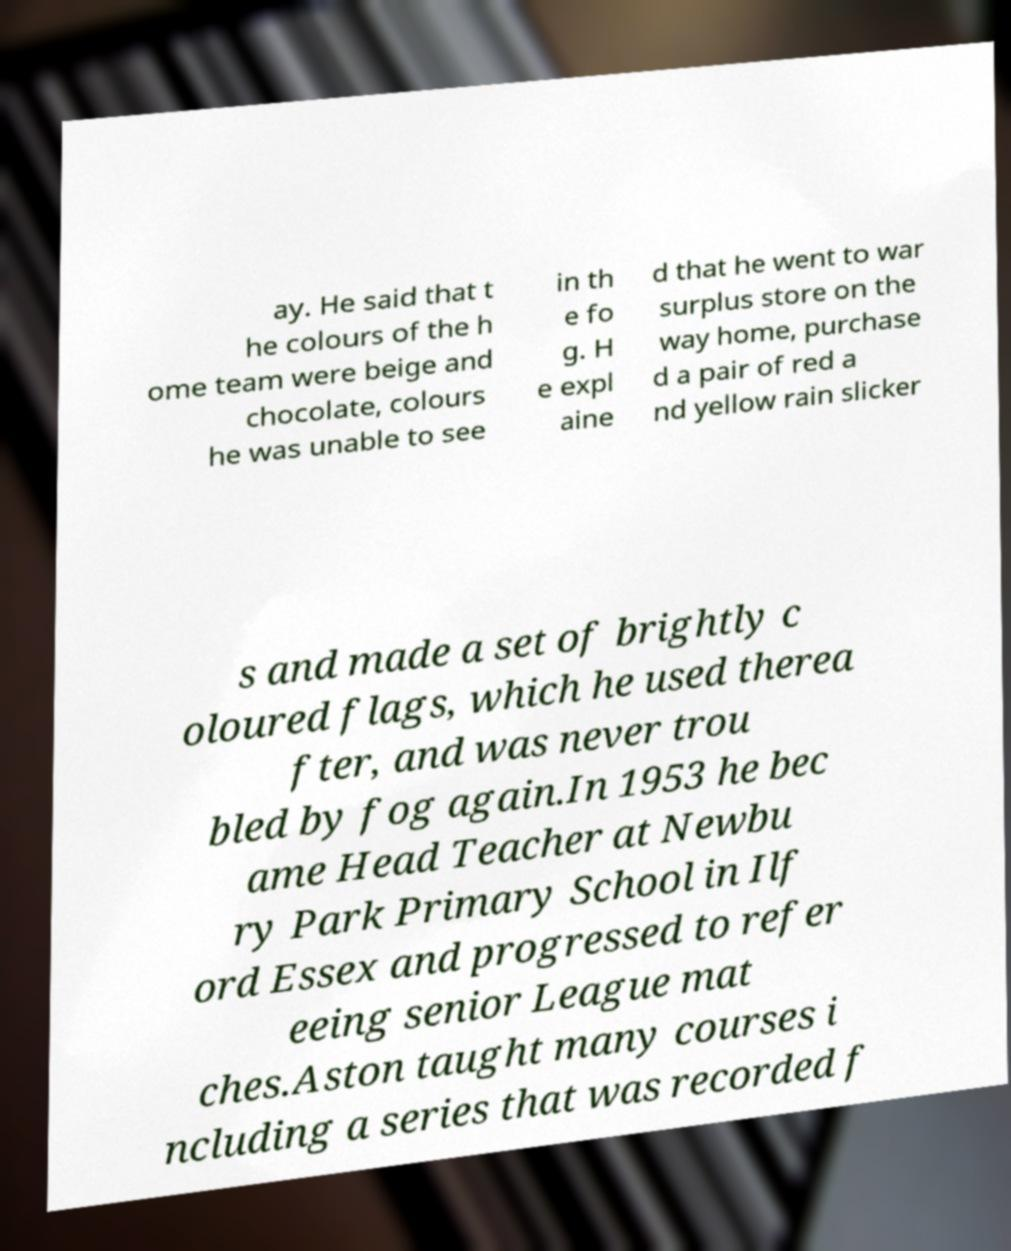What messages or text are displayed in this image? I need them in a readable, typed format. ay. He said that t he colours of the h ome team were beige and chocolate, colours he was unable to see in th e fo g. H e expl aine d that he went to war surplus store on the way home, purchase d a pair of red a nd yellow rain slicker s and made a set of brightly c oloured flags, which he used therea fter, and was never trou bled by fog again.In 1953 he bec ame Head Teacher at Newbu ry Park Primary School in Ilf ord Essex and progressed to refer eeing senior League mat ches.Aston taught many courses i ncluding a series that was recorded f 